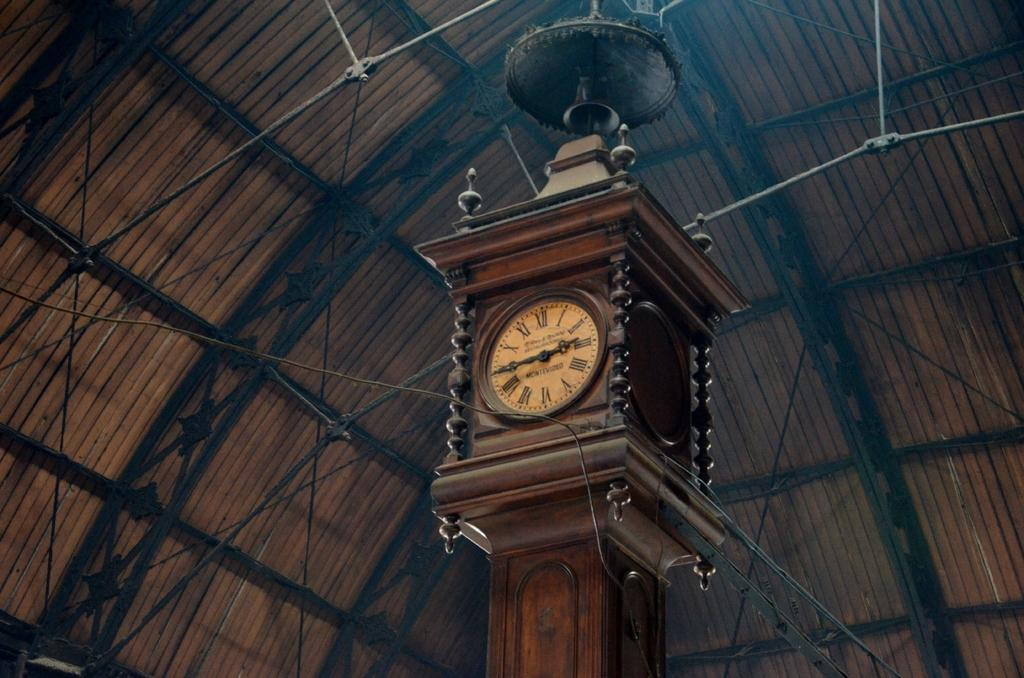<image>
Relay a brief, clear account of the picture shown. An ornate clock has the word Montevideo within the circle of its Roman numerals. 